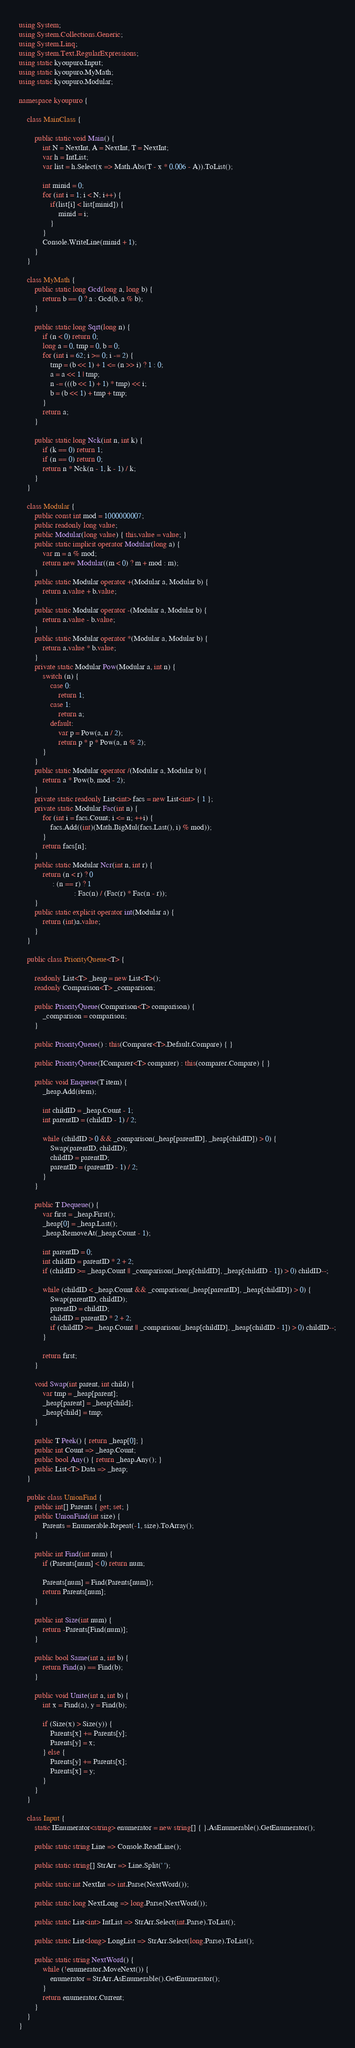Convert code to text. <code><loc_0><loc_0><loc_500><loc_500><_C#_>using System;
using System.Collections.Generic;
using System.Linq;
using System.Text.RegularExpressions;
using static kyoupuro.Input;
using static kyoupuro.MyMath;
using static kyoupuro.Modular;

namespace kyoupuro {

    class MainClass {

        public static void Main() {
            int N = NextInt, A = NextInt, T = NextInt;
            var h = IntList;
            var list = h.Select(x => Math.Abs(T - x * 0.006 - A)).ToList();

            int minid = 0;
            for (int i = 1; i < N; i++) {
                if(list[i] < list[minid]) {
                    minid = i;
                }
            }
            Console.WriteLine(minid + 1);
        }
    }

    class MyMath {
        public static long Gcd(long a, long b) {
            return b == 0 ? a : Gcd(b, a % b);
        }

        public static long Sqrt(long n) {
            if (n < 0) return 0;
            long a = 0, tmp = 0, b = 0;
            for (int i = 62; i >= 0; i -= 2) {
                tmp = (b << 1) + 1 <= (n >> i) ? 1 : 0;
                a = a << 1 | tmp;
                n -= (((b << 1) + 1) * tmp) << i;
                b = (b << 1) + tmp + tmp;
            }
            return a;
        }

        public static long Nck(int n, int k) {
            if (k == 0) return 1;
            if (n == 0) return 0;
            return n * Nck(n - 1, k - 1) / k;
        }
    }

    class Modular {
        public const int mod = 1000000007;
        public readonly long value;
        public Modular(long value) { this.value = value; }
        public static implicit operator Modular(long a) {
            var m = a % mod;
            return new Modular((m < 0) ? m + mod : m);
        }
        public static Modular operator +(Modular a, Modular b) {
            return a.value + b.value;
        }
        public static Modular operator -(Modular a, Modular b) {
            return a.value - b.value;
        }
        public static Modular operator *(Modular a, Modular b) {
            return a.value * b.value;
        }
        private static Modular Pow(Modular a, int n) {
            switch (n) {
                case 0:
                    return 1;
                case 1:
                    return a;
                default:
                    var p = Pow(a, n / 2);
                    return p * p * Pow(a, n % 2);
            }
        }
        public static Modular operator /(Modular a, Modular b) {
            return a * Pow(b, mod - 2);
        }
        private static readonly List<int> facs = new List<int> { 1 };
        private static Modular Fac(int n) {
            for (int i = facs.Count; i <= n; ++i) {
                facs.Add((int)(Math.BigMul(facs.Last(), i) % mod));
            }
            return facs[n];
        }
        public static Modular Ncr(int n, int r) {
            return (n < r) ? 0
                 : (n == r) ? 1
                            : Fac(n) / (Fac(r) * Fac(n - r));
        }
        public static explicit operator int(Modular a) {
            return (int)a.value;
        }
    }

    public class PriorityQueue<T> {

        readonly List<T> _heap = new List<T>();
        readonly Comparison<T> _comparison;

        public PriorityQueue(Comparison<T> comparison) {
            _comparison = comparison;
        }

        public PriorityQueue() : this(Comparer<T>.Default.Compare) { }

        public PriorityQueue(IComparer<T> comparer) : this(comparer.Compare) { }

        public void Enqueue(T item) {
            _heap.Add(item);

            int childID = _heap.Count - 1;
            int parentID = (childID - 1) / 2;

            while (childID > 0 && _comparison(_heap[parentID], _heap[childID]) > 0) {
                Swap(parentID, childID);
                childID = parentID;
                parentID = (parentID - 1) / 2;
            }
        }

        public T Dequeue() {
            var first = _heap.First();
            _heap[0] = _heap.Last();
            _heap.RemoveAt(_heap.Count - 1);

            int parentID = 0;
            int childID = parentID * 2 + 2;
            if (childID >= _heap.Count || _comparison(_heap[childID], _heap[childID - 1]) > 0) childID--;

            while (childID < _heap.Count && _comparison(_heap[parentID], _heap[childID]) > 0) {
                Swap(parentID, childID);
                parentID = childID;
                childID = parentID * 2 + 2;
                if (childID >= _heap.Count || _comparison(_heap[childID], _heap[childID - 1]) > 0) childID--;
            }

            return first;
        }

        void Swap(int parent, int child) {
            var tmp = _heap[parent];
            _heap[parent] = _heap[child];
            _heap[child] = tmp;
        }

        public T Peek() { return _heap[0]; }
        public int Count => _heap.Count;
        public bool Any() { return _heap.Any(); }
        public List<T> Data => _heap;
    }

    public class UnionFind {
        public int[] Parents { get; set; }
        public UnionFind(int size) {
            Parents = Enumerable.Repeat(-1, size).ToArray();
        }

        public int Find(int num) {
            if (Parents[num] < 0) return num;

            Parents[num] = Find(Parents[num]);
            return Parents[num];
        }

        public int Size(int num) {
            return -Parents[Find(num)];
        }

        public bool Same(int a, int b) {
            return Find(a) == Find(b);
        }

        public void Unite(int a, int b) {
            int x = Find(a), y = Find(b);

            if (Size(x) > Size(y)) {
                Parents[x] += Parents[y];
                Parents[y] = x;
            } else {
                Parents[y] += Parents[x];
                Parents[x] = y;
            }
        }
    }

    class Input {
        static IEnumerator<string> enumerator = new string[] { }.AsEnumerable().GetEnumerator();

        public static string Line => Console.ReadLine();

        public static string[] StrArr => Line.Split(' ');

        public static int NextInt => int.Parse(NextWord());

        public static long NextLong => long.Parse(NextWord());

        public static List<int> IntList => StrArr.Select(int.Parse).ToList();

        public static List<long> LongList => StrArr.Select(long.Parse).ToList();

        public static string NextWord() {
            while (!enumerator.MoveNext()) {
                enumerator = StrArr.AsEnumerable().GetEnumerator();
            }
            return enumerator.Current;
        }
    }
}
</code> 